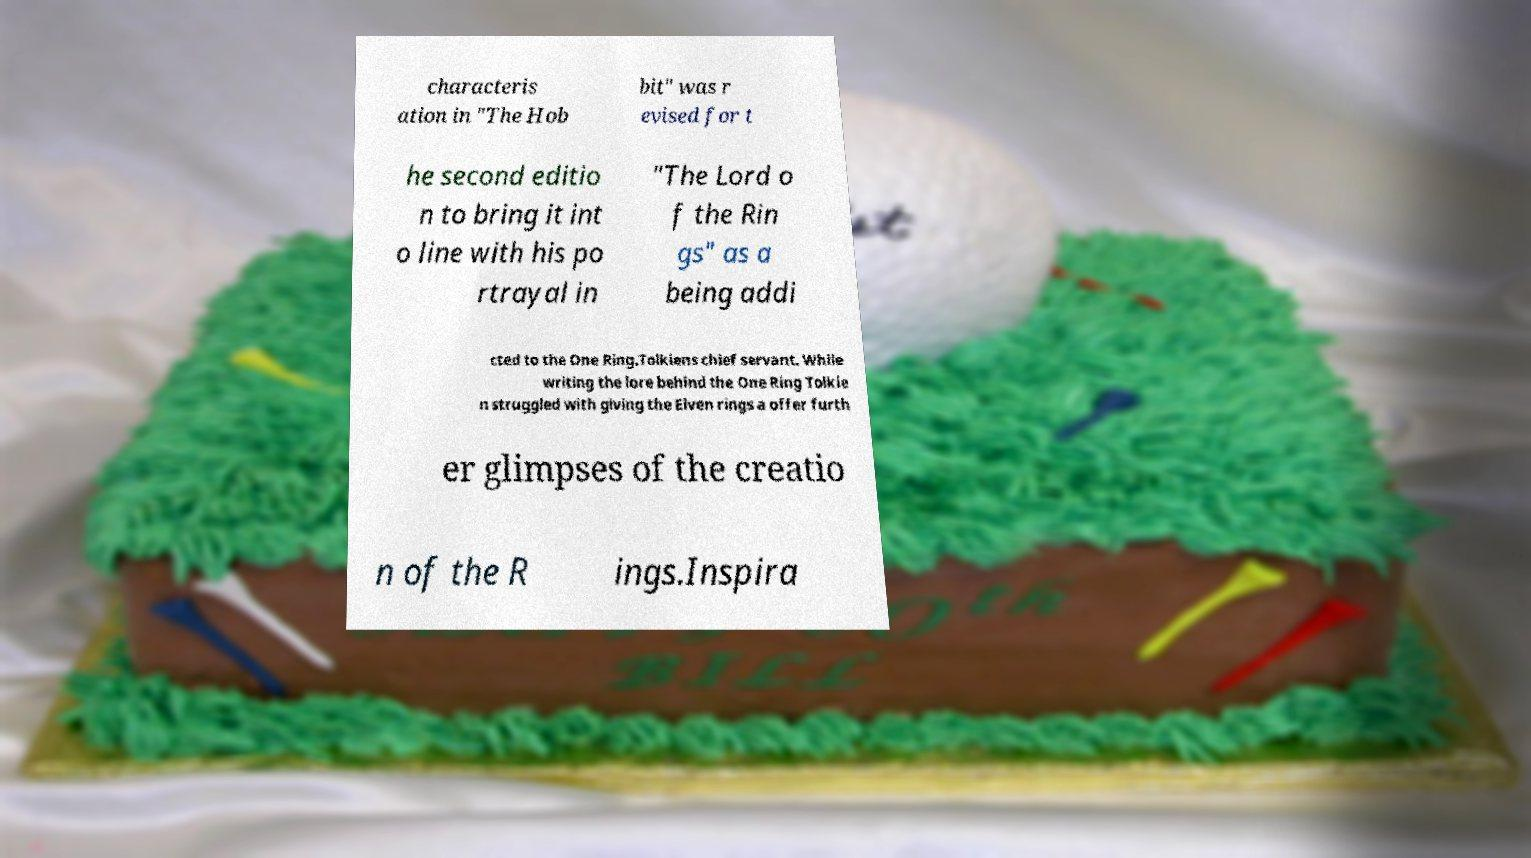Could you assist in decoding the text presented in this image and type it out clearly? characteris ation in "The Hob bit" was r evised for t he second editio n to bring it int o line with his po rtrayal in "The Lord o f the Rin gs" as a being addi cted to the One Ring.Tolkiens chief servant. While writing the lore behind the One Ring Tolkie n struggled with giving the Elven rings a offer furth er glimpses of the creatio n of the R ings.Inspira 